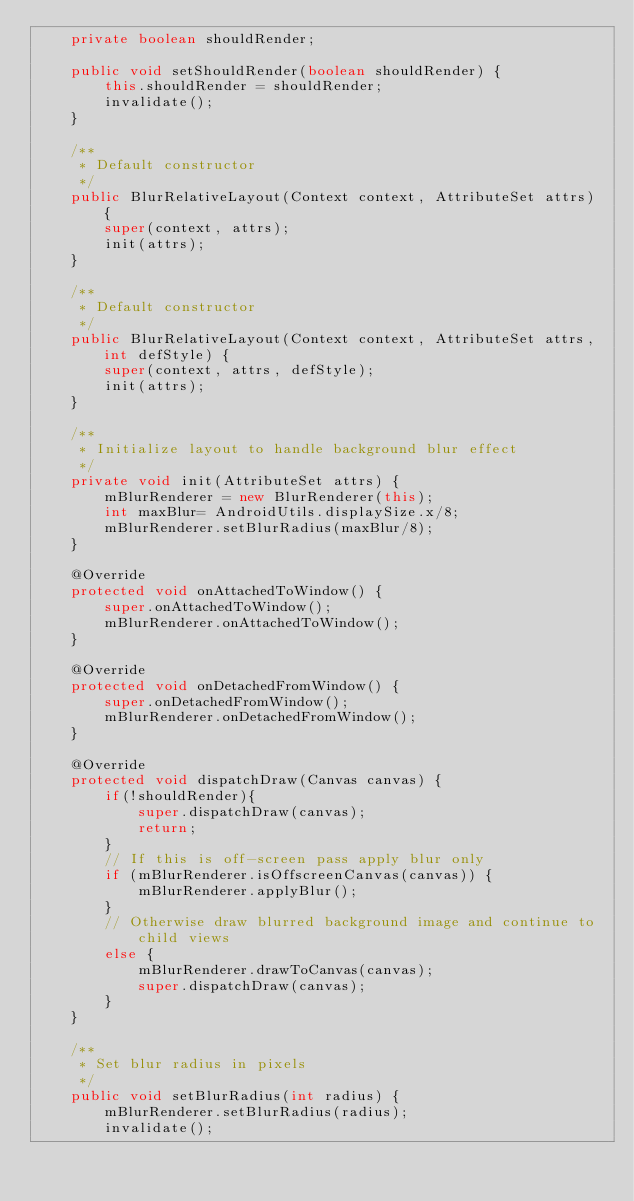Convert code to text. <code><loc_0><loc_0><loc_500><loc_500><_Java_>    private boolean shouldRender;

    public void setShouldRender(boolean shouldRender) {
        this.shouldRender = shouldRender;
        invalidate();
    }

    /**
     * Default constructor
     */
    public BlurRelativeLayout(Context context, AttributeSet attrs) {
        super(context, attrs);
        init(attrs);
    }

    /**
     * Default constructor
     */
    public BlurRelativeLayout(Context context, AttributeSet attrs, int defStyle) {
        super(context, attrs, defStyle);
        init(attrs);
    }

    /**
     * Initialize layout to handle background blur effect
     */
    private void init(AttributeSet attrs) {
        mBlurRenderer = new BlurRenderer(this);
        int maxBlur= AndroidUtils.displaySize.x/8;
        mBlurRenderer.setBlurRadius(maxBlur/8);
    }

    @Override
    protected void onAttachedToWindow() {
        super.onAttachedToWindow();
        mBlurRenderer.onAttachedToWindow();
    }

    @Override
    protected void onDetachedFromWindow() {
        super.onDetachedFromWindow();
        mBlurRenderer.onDetachedFromWindow();
    }

    @Override
    protected void dispatchDraw(Canvas canvas) {
        if(!shouldRender){
            super.dispatchDraw(canvas);
            return;
        }
        // If this is off-screen pass apply blur only
        if (mBlurRenderer.isOffscreenCanvas(canvas)) {
            mBlurRenderer.applyBlur();
        }
        // Otherwise draw blurred background image and continue to child views
        else {
            mBlurRenderer.drawToCanvas(canvas);
            super.dispatchDraw(canvas);
        }
    }

    /**
     * Set blur radius in pixels
     */
    public void setBlurRadius(int radius) {
        mBlurRenderer.setBlurRadius(radius);
        invalidate();</code> 